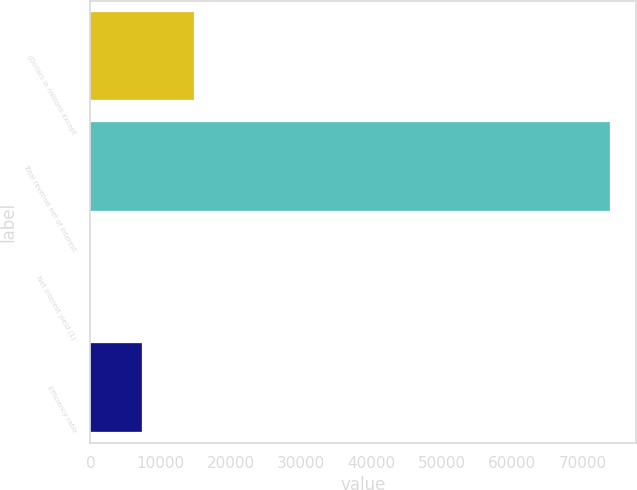<chart> <loc_0><loc_0><loc_500><loc_500><bar_chart><fcel>(Dollars in millions except<fcel>Total revenue net of interest<fcel>Net interest yield (1)<fcel>Efficiency ratio<nl><fcel>14797.6<fcel>73976<fcel>2.98<fcel>7400.28<nl></chart> 